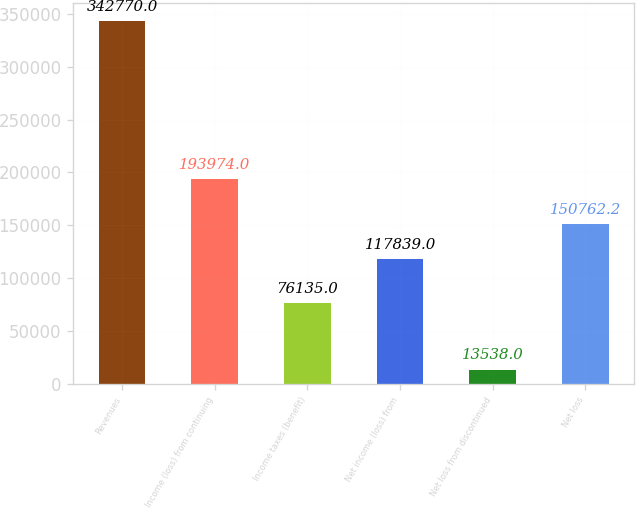<chart> <loc_0><loc_0><loc_500><loc_500><bar_chart><fcel>Revenues<fcel>Income (loss) from continuing<fcel>Income taxes (benefit)<fcel>Net income (loss) from<fcel>Net loss from discontinued<fcel>Net loss<nl><fcel>342770<fcel>193974<fcel>76135<fcel>117839<fcel>13538<fcel>150762<nl></chart> 